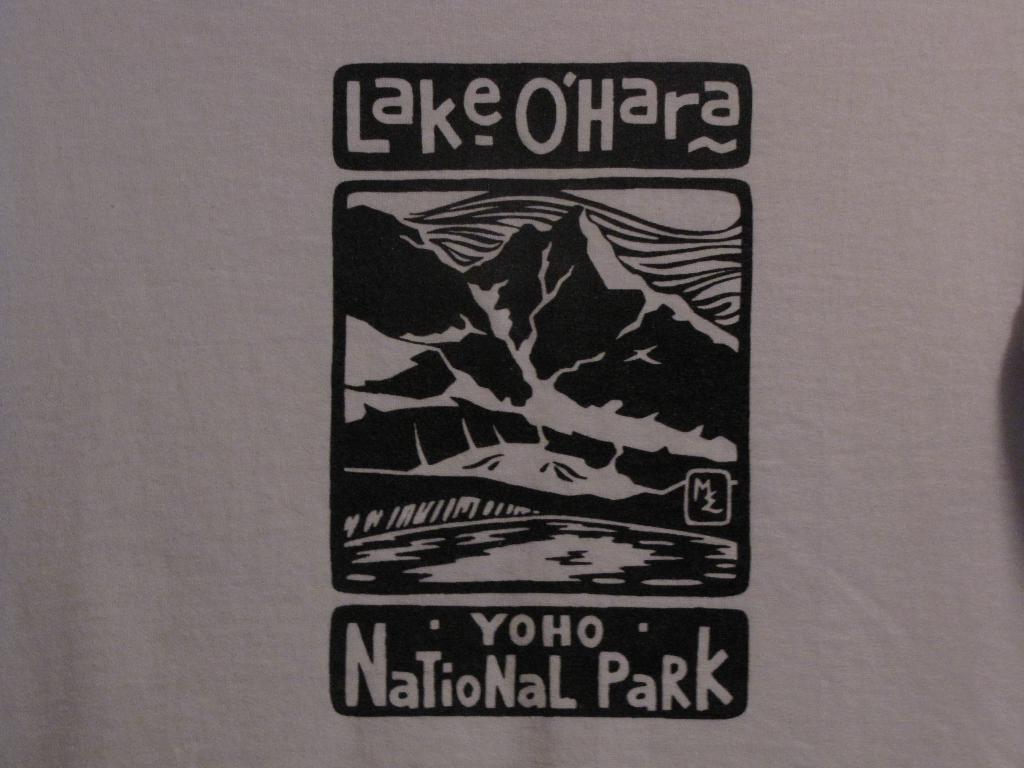Describe this image in one or two sentences. In this picture we can see an art and text on the plane surface. 